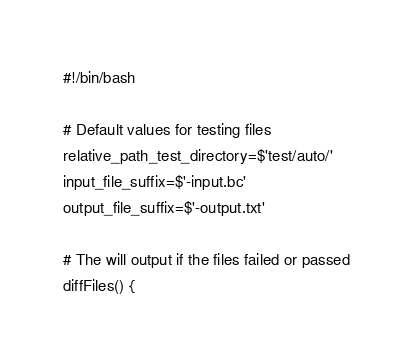Convert code to text. <code><loc_0><loc_0><loc_500><loc_500><_Bash_>#!/bin/bash

# Default values for testing files
relative_path_test_directory=$'test/auto/'
input_file_suffix=$'-input.bc'
output_file_suffix=$'-output.txt'

# The will output if the files failed or passed
diffFiles() {</code> 